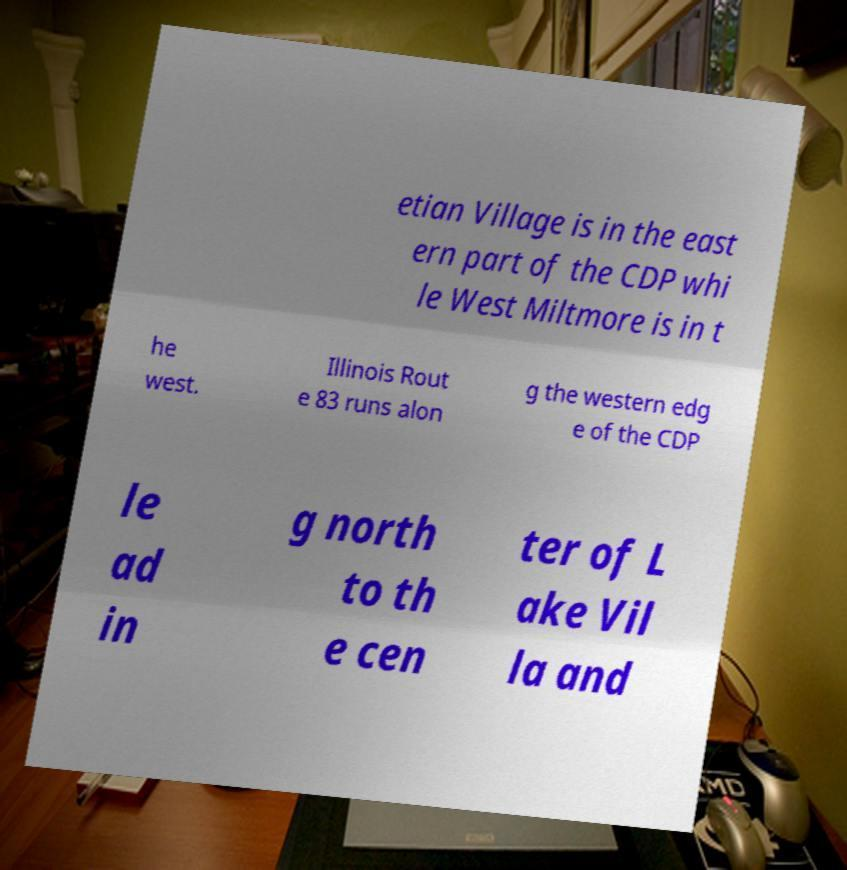What messages or text are displayed in this image? I need them in a readable, typed format. etian Village is in the east ern part of the CDP whi le West Miltmore is in t he west. Illinois Rout e 83 runs alon g the western edg e of the CDP le ad in g north to th e cen ter of L ake Vil la and 